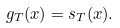<formula> <loc_0><loc_0><loc_500><loc_500>g _ { T } ( x ) = s _ { T } ( x ) .</formula> 